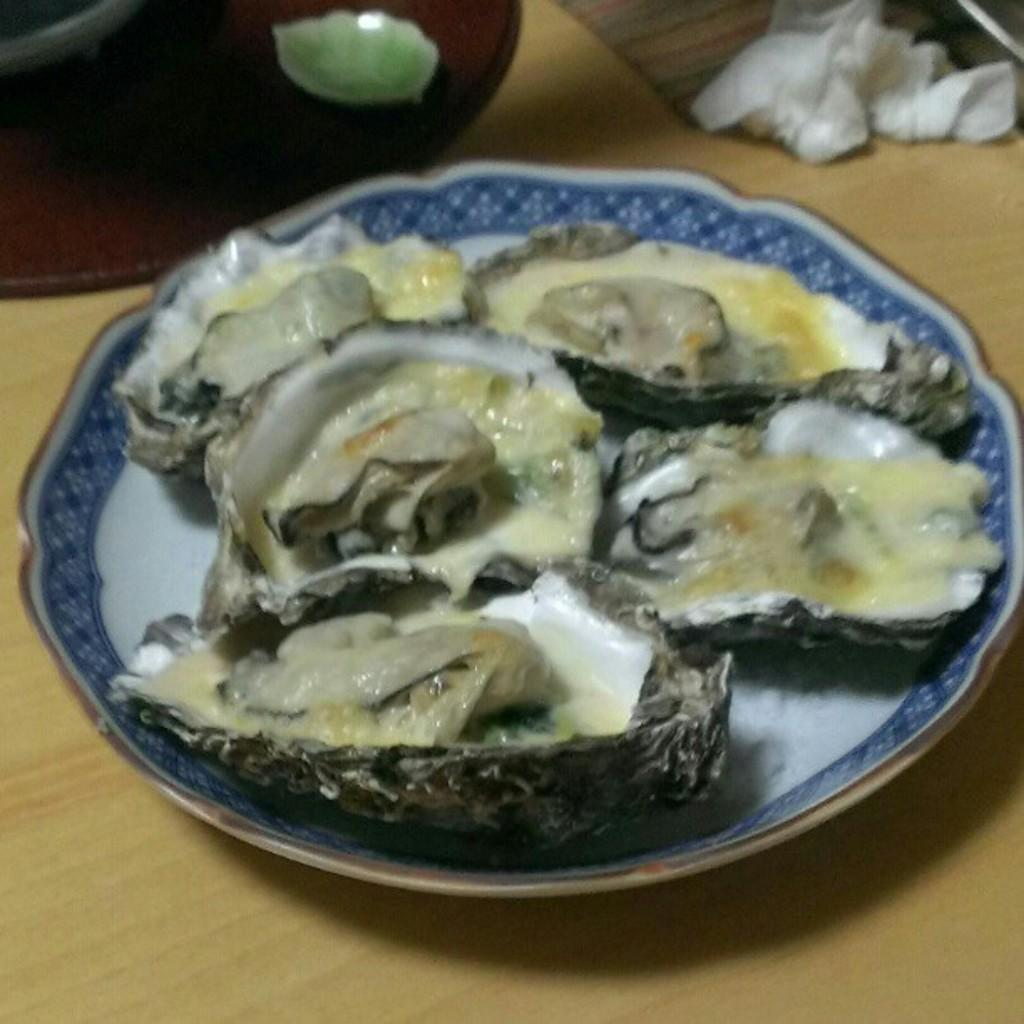What is present on the surface in the image? There is a plate in the image. What is on the plate in the image? There is food in the image. What is under the plate in the image? There is a mat in the image. What is the wooden platform supporting in the image? There are objects on a wooden platform in the image. What type of acoustics can be heard coming from the bell in the image? There is no bell present in the image, so it is not possible to determine what, if any, acoustics might be heard. 